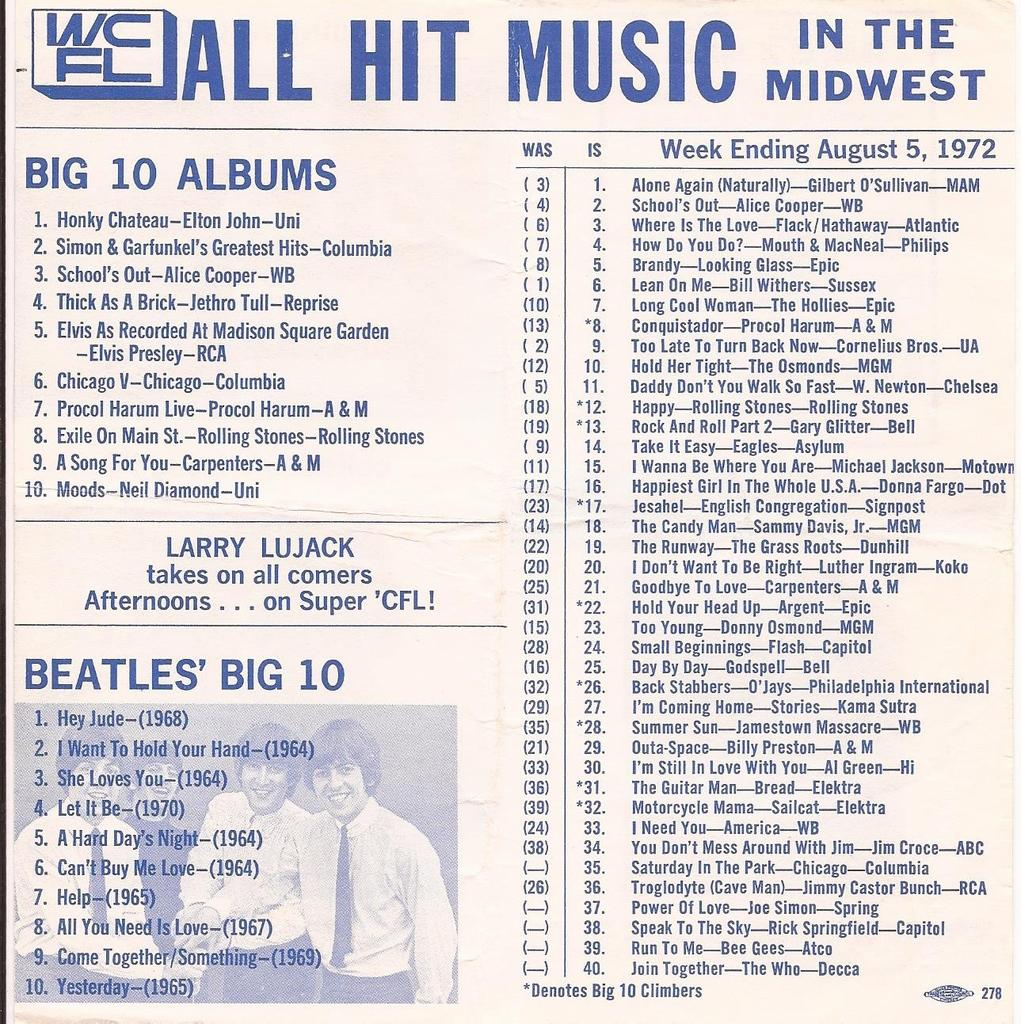What type of page is shown in the image? There is an index page in the image. What is written at the top of the page? The phrase "all hit music" is written at the top of the page. How many names are listed on the page? There is a list of 40 names on the page. How much payment is required to access the control panel in the image? There is no control panel or payment mentioned in the image; it only shows an index page with a list of names and a phrase at the top. 